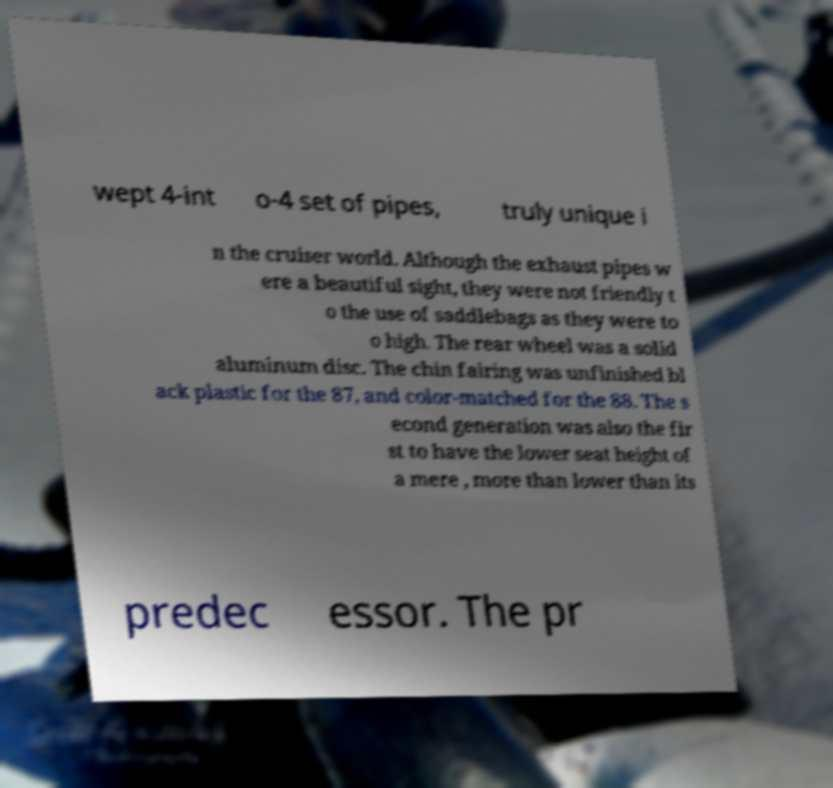Can you read and provide the text displayed in the image?This photo seems to have some interesting text. Can you extract and type it out for me? wept 4-int o-4 set of pipes, truly unique i n the cruiser world. Although the exhaust pipes w ere a beautiful sight, they were not friendly t o the use of saddlebags as they were to o high. The rear wheel was a solid aluminum disc. The chin fairing was unfinished bl ack plastic for the 87, and color-matched for the 88. The s econd generation was also the fir st to have the lower seat height of a mere , more than lower than its predec essor. The pr 